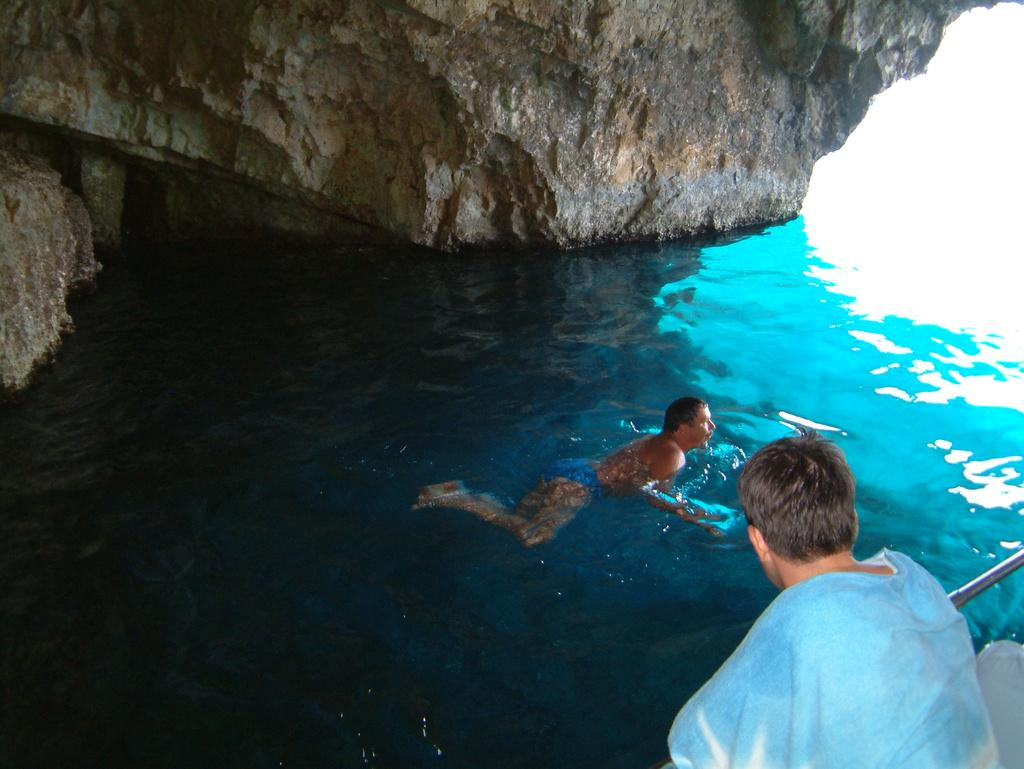Where is the person sitting in the image? The person is sitting in the bottom right corner of the image. What is the other person in the image doing? The other person is swimming in the water in the image. What type of bears can be seen playing with a finger in the image? There are no bears or fingers present in the image; it features two people, one sitting and the other swimming. What phase of the moon is visible in the image? There is no moon visible in the image. 